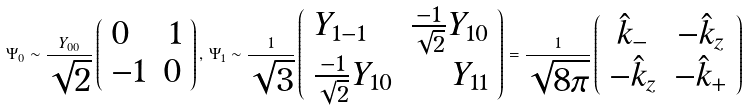<formula> <loc_0><loc_0><loc_500><loc_500>\Psi _ { 0 } \sim \frac { Y _ { 0 0 } } { \sqrt { 2 } } \left ( \begin{array} { l r } 0 & 1 \\ - 1 & 0 \\ \end{array} \right ) , \, \Psi _ { 1 } \sim \frac { 1 } { \sqrt { 3 } } \left ( \begin{array} { l r } Y _ { 1 - 1 } & \frac { - 1 } { \sqrt { 2 } } Y _ { 1 0 } \\ \frac { - 1 } { \sqrt { 2 } } Y _ { 1 0 } & Y _ { 1 1 } \end{array} \right ) = \frac { 1 } { \sqrt { 8 \pi } } \left ( \begin{array} { c c } \hat { k } _ { - } & - \hat { k } _ { z } \\ - \hat { k } _ { z } & - \hat { k } _ { + } \\ \end{array} \right )</formula> 